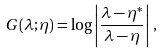Convert formula to latex. <formula><loc_0><loc_0><loc_500><loc_500>G ( \lambda ; \eta ) = \log \left | \frac { \lambda - \eta ^ { * } } { \lambda - \eta } \right | \, ,</formula> 